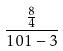Convert formula to latex. <formula><loc_0><loc_0><loc_500><loc_500>\frac { \frac { 8 } { 4 } } { 1 0 1 - 3 }</formula> 